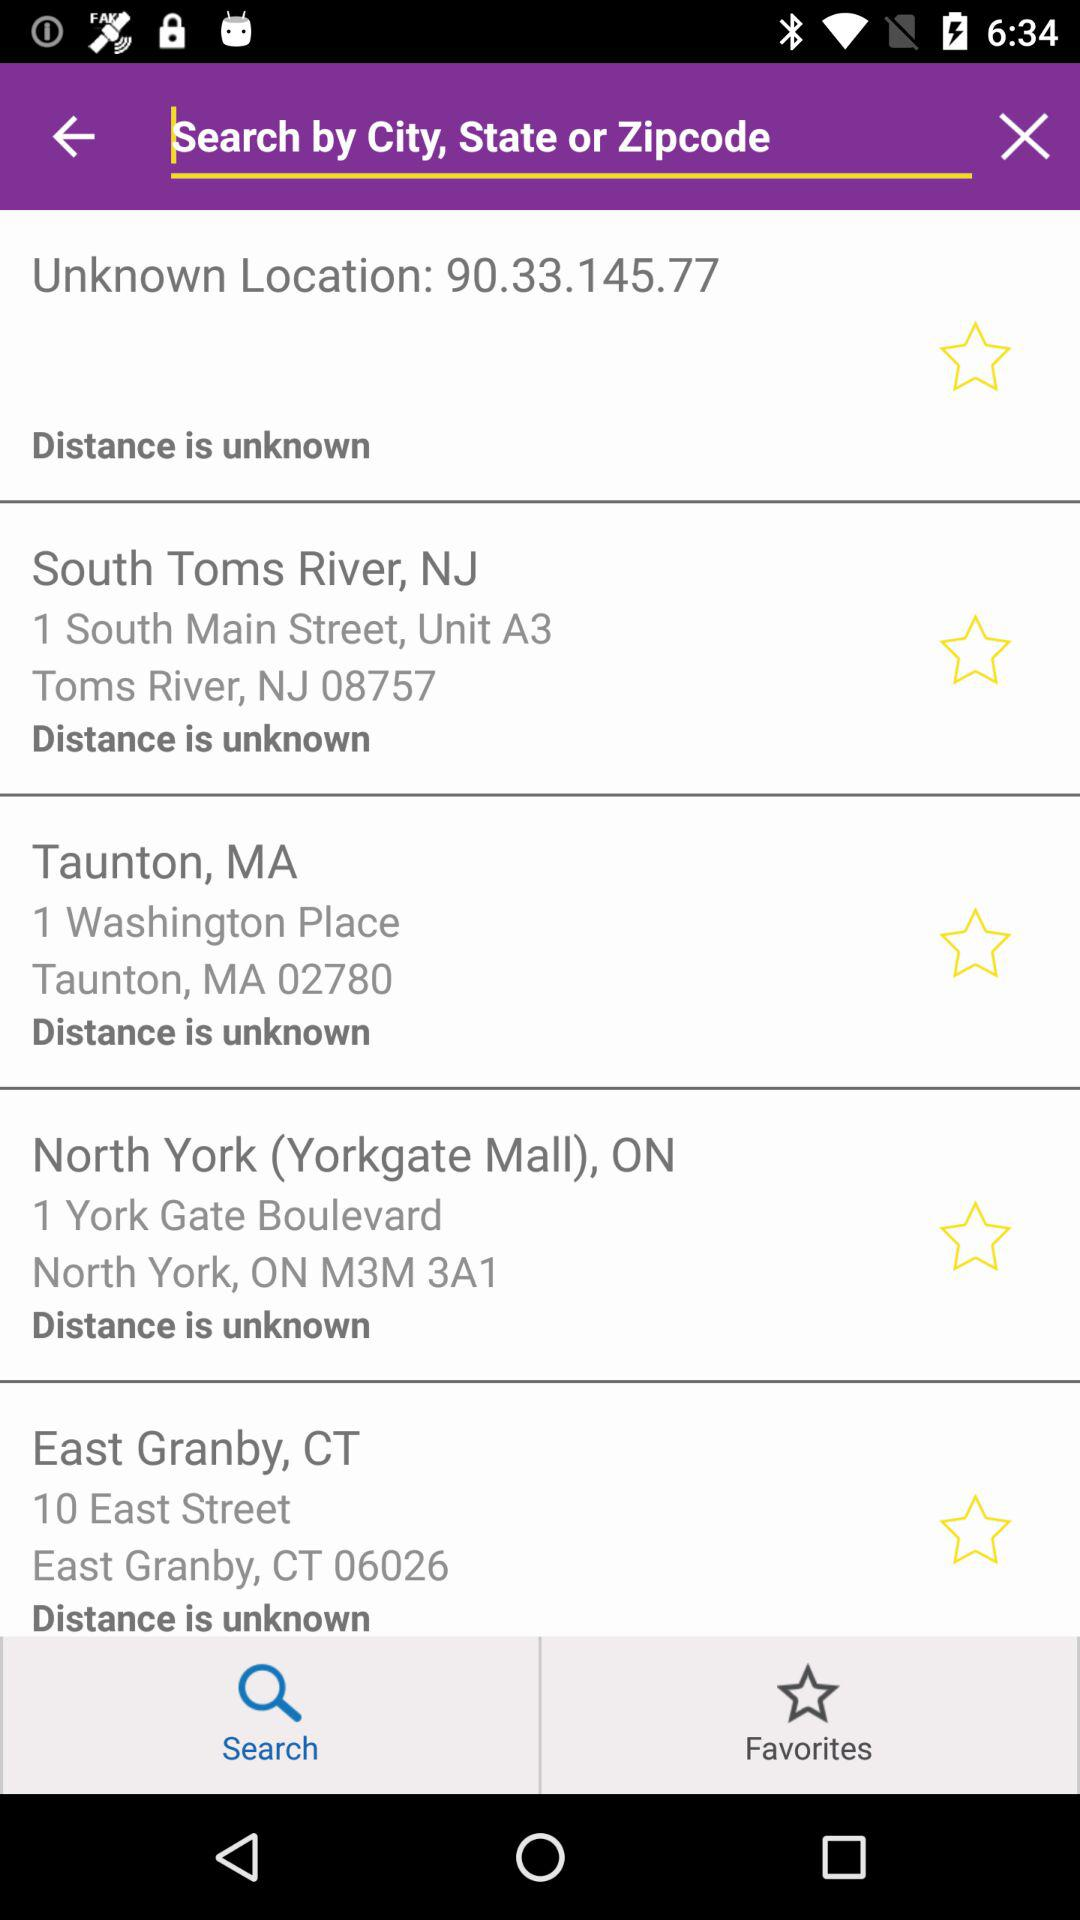What is the address mentioned in "East Granby, CT"? The mentioned address is 10 East Street, East Granby, CT 06026. 